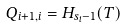<formula> <loc_0><loc_0><loc_500><loc_500>Q _ { i + 1 , i } = H _ { s _ { i } - 1 } ( T )</formula> 